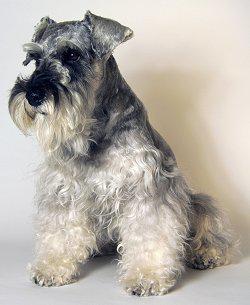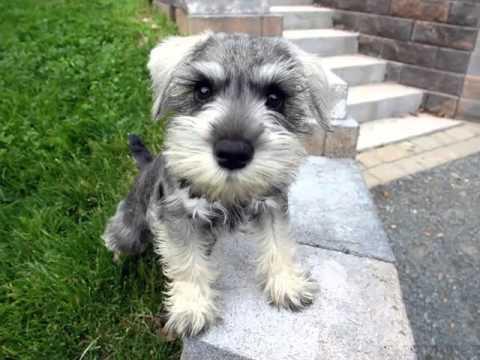The first image is the image on the left, the second image is the image on the right. Analyze the images presented: Is the assertion "The left image shows a schnauzer sitting upright." valid? Answer yes or no. Yes. 